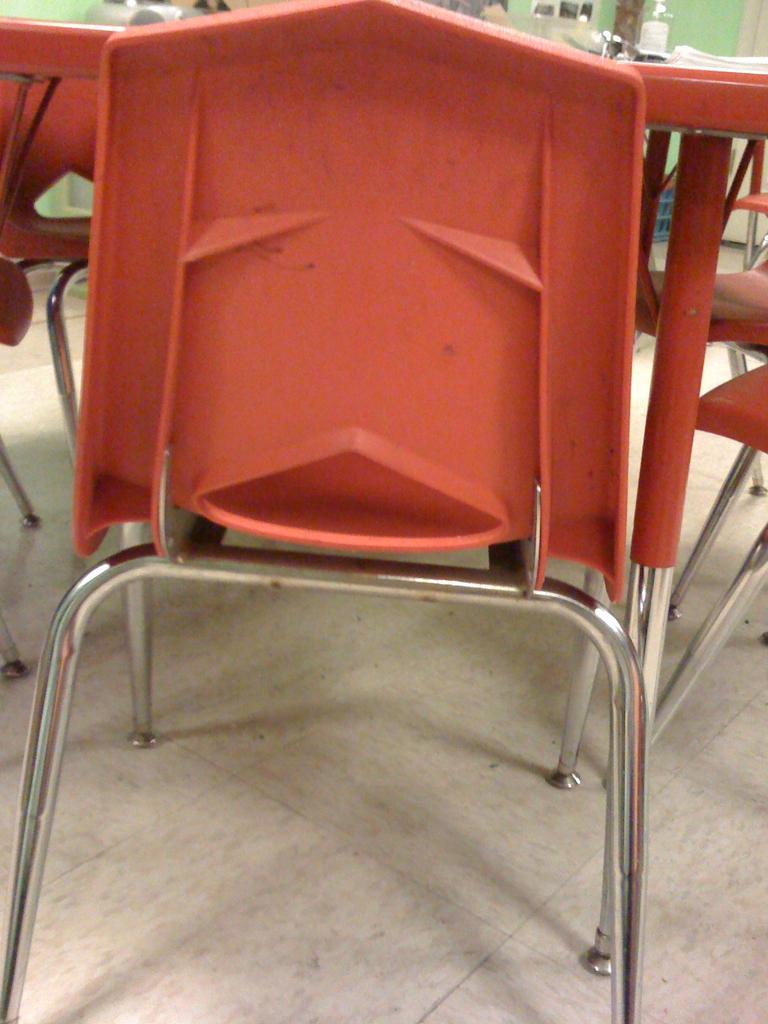How would you summarize this image in a sentence or two? In this image we can see a group of chairs and table placed on the ground. In the background, we can see a basket and a wall. 